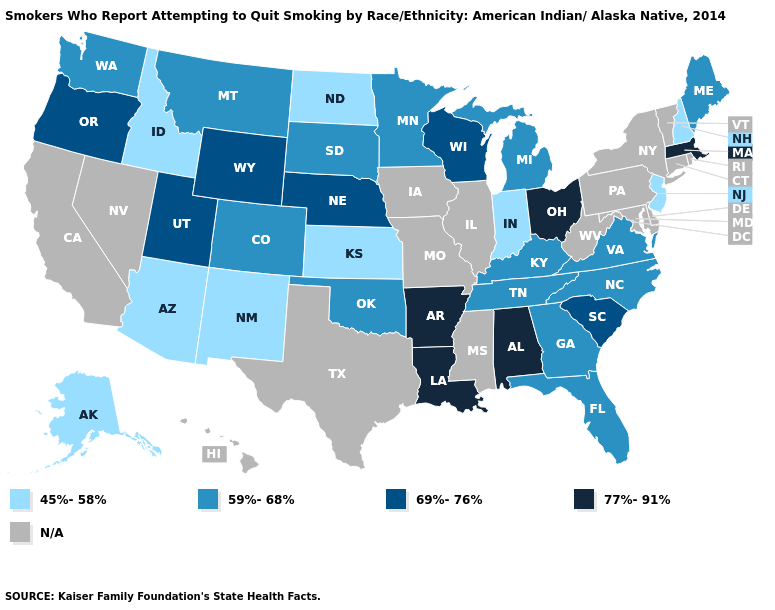What is the highest value in states that border Illinois?
Write a very short answer. 69%-76%. Does Ohio have the highest value in the USA?
Quick response, please. Yes. Does the map have missing data?
Keep it brief. Yes. What is the value of Tennessee?
Concise answer only. 59%-68%. What is the value of Utah?
Answer briefly. 69%-76%. Among the states that border Nebraska , which have the lowest value?
Give a very brief answer. Kansas. Name the states that have a value in the range 59%-68%?
Answer briefly. Colorado, Florida, Georgia, Kentucky, Maine, Michigan, Minnesota, Montana, North Carolina, Oklahoma, South Dakota, Tennessee, Virginia, Washington. What is the highest value in the Northeast ?
Concise answer only. 77%-91%. Which states have the highest value in the USA?
Answer briefly. Alabama, Arkansas, Louisiana, Massachusetts, Ohio. What is the value of South Dakota?
Quick response, please. 59%-68%. Among the states that border Florida , which have the highest value?
Short answer required. Alabama. What is the value of Maine?
Be succinct. 59%-68%. What is the lowest value in the West?
Answer briefly. 45%-58%. Which states have the highest value in the USA?
Concise answer only. Alabama, Arkansas, Louisiana, Massachusetts, Ohio. 